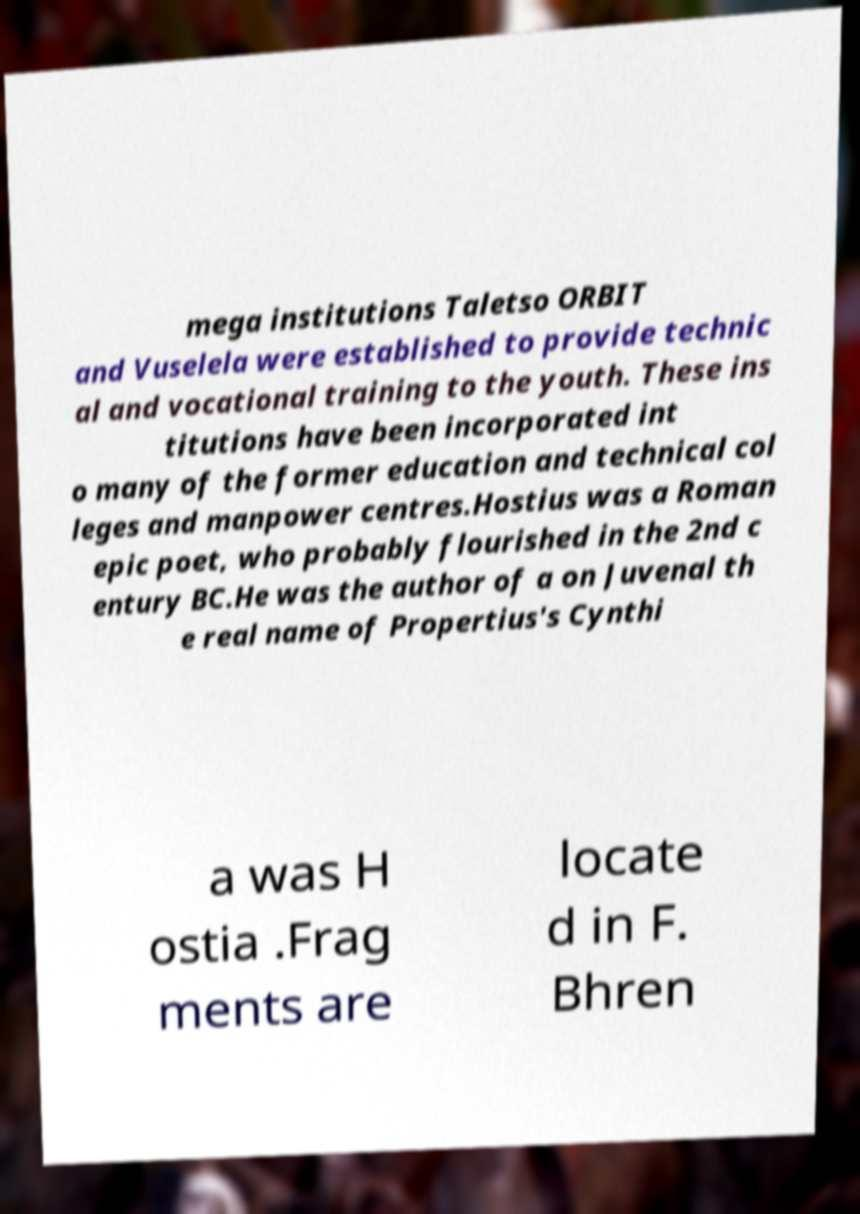Could you assist in decoding the text presented in this image and type it out clearly? mega institutions Taletso ORBIT and Vuselela were established to provide technic al and vocational training to the youth. These ins titutions have been incorporated int o many of the former education and technical col leges and manpower centres.Hostius was a Roman epic poet, who probably flourished in the 2nd c entury BC.He was the author of a on Juvenal th e real name of Propertius's Cynthi a was H ostia .Frag ments are locate d in F. Bhren 